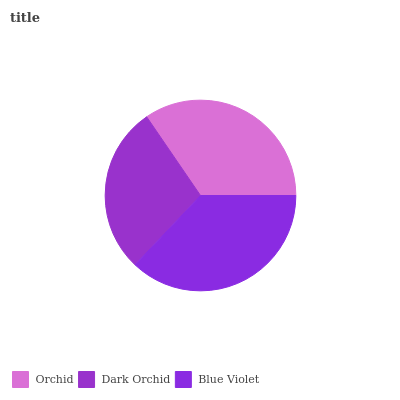Is Dark Orchid the minimum?
Answer yes or no. Yes. Is Blue Violet the maximum?
Answer yes or no. Yes. Is Blue Violet the minimum?
Answer yes or no. No. Is Dark Orchid the maximum?
Answer yes or no. No. Is Blue Violet greater than Dark Orchid?
Answer yes or no. Yes. Is Dark Orchid less than Blue Violet?
Answer yes or no. Yes. Is Dark Orchid greater than Blue Violet?
Answer yes or no. No. Is Blue Violet less than Dark Orchid?
Answer yes or no. No. Is Orchid the high median?
Answer yes or no. Yes. Is Orchid the low median?
Answer yes or no. Yes. Is Blue Violet the high median?
Answer yes or no. No. Is Blue Violet the low median?
Answer yes or no. No. 